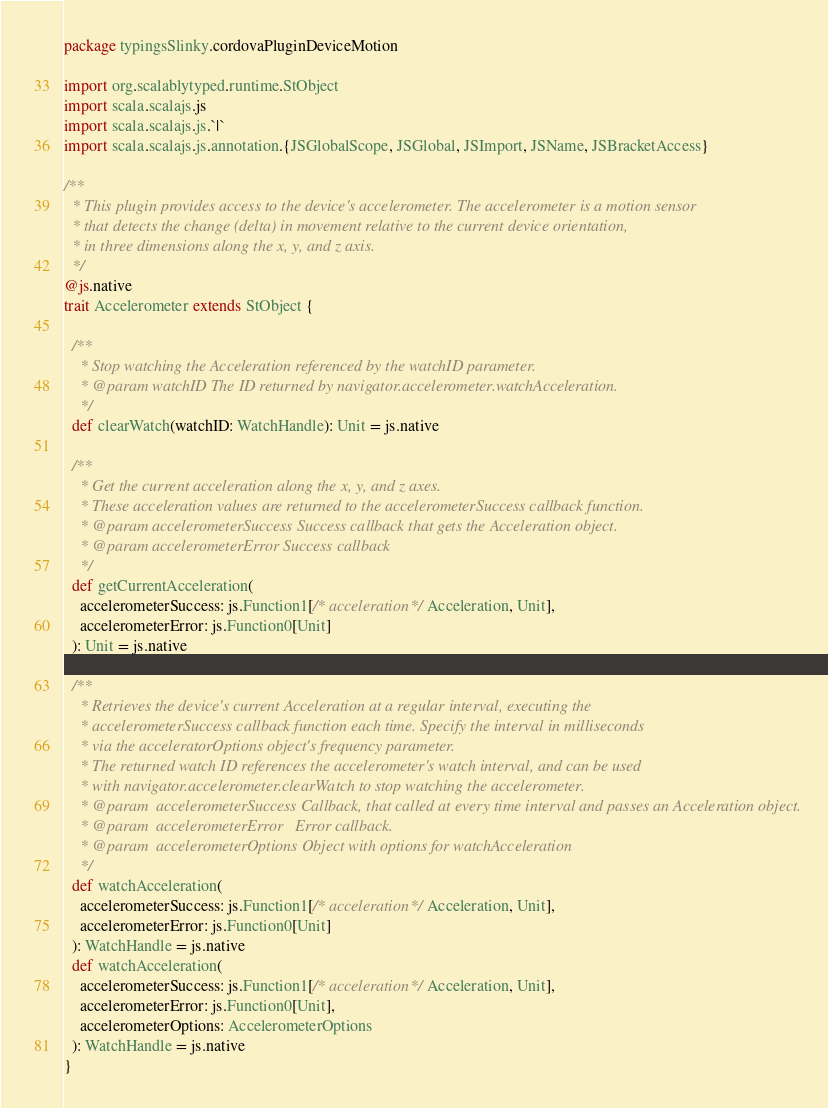<code> <loc_0><loc_0><loc_500><loc_500><_Scala_>package typingsSlinky.cordovaPluginDeviceMotion

import org.scalablytyped.runtime.StObject
import scala.scalajs.js
import scala.scalajs.js.`|`
import scala.scalajs.js.annotation.{JSGlobalScope, JSGlobal, JSImport, JSName, JSBracketAccess}

/**
  * This plugin provides access to the device's accelerometer. The accelerometer is a motion sensor
  * that detects the change (delta) in movement relative to the current device orientation,
  * in three dimensions along the x, y, and z axis.
  */
@js.native
trait Accelerometer extends StObject {
  
  /**
    * Stop watching the Acceleration referenced by the watchID parameter.
    * @param watchID The ID returned by navigator.accelerometer.watchAcceleration.
    */
  def clearWatch(watchID: WatchHandle): Unit = js.native
  
  /**
    * Get the current acceleration along the x, y, and z axes.
    * These acceleration values are returned to the accelerometerSuccess callback function.
    * @param accelerometerSuccess Success callback that gets the Acceleration object.
    * @param accelerometerError Success callback
    */
  def getCurrentAcceleration(
    accelerometerSuccess: js.Function1[/* acceleration */ Acceleration, Unit],
    accelerometerError: js.Function0[Unit]
  ): Unit = js.native
  
  /**
    * Retrieves the device's current Acceleration at a regular interval, executing the
    * accelerometerSuccess callback function each time. Specify the interval in milliseconds
    * via the acceleratorOptions object's frequency parameter.
    * The returned watch ID references the accelerometer's watch interval, and can be used
    * with navigator.accelerometer.clearWatch to stop watching the accelerometer.
    * @param  accelerometerSuccess Callback, that called at every time interval and passes an Acceleration object.
    * @param  accelerometerError   Error callback.
    * @param  accelerometerOptions Object with options for watchAcceleration
    */
  def watchAcceleration(
    accelerometerSuccess: js.Function1[/* acceleration */ Acceleration, Unit],
    accelerometerError: js.Function0[Unit]
  ): WatchHandle = js.native
  def watchAcceleration(
    accelerometerSuccess: js.Function1[/* acceleration */ Acceleration, Unit],
    accelerometerError: js.Function0[Unit],
    accelerometerOptions: AccelerometerOptions
  ): WatchHandle = js.native
}
</code> 